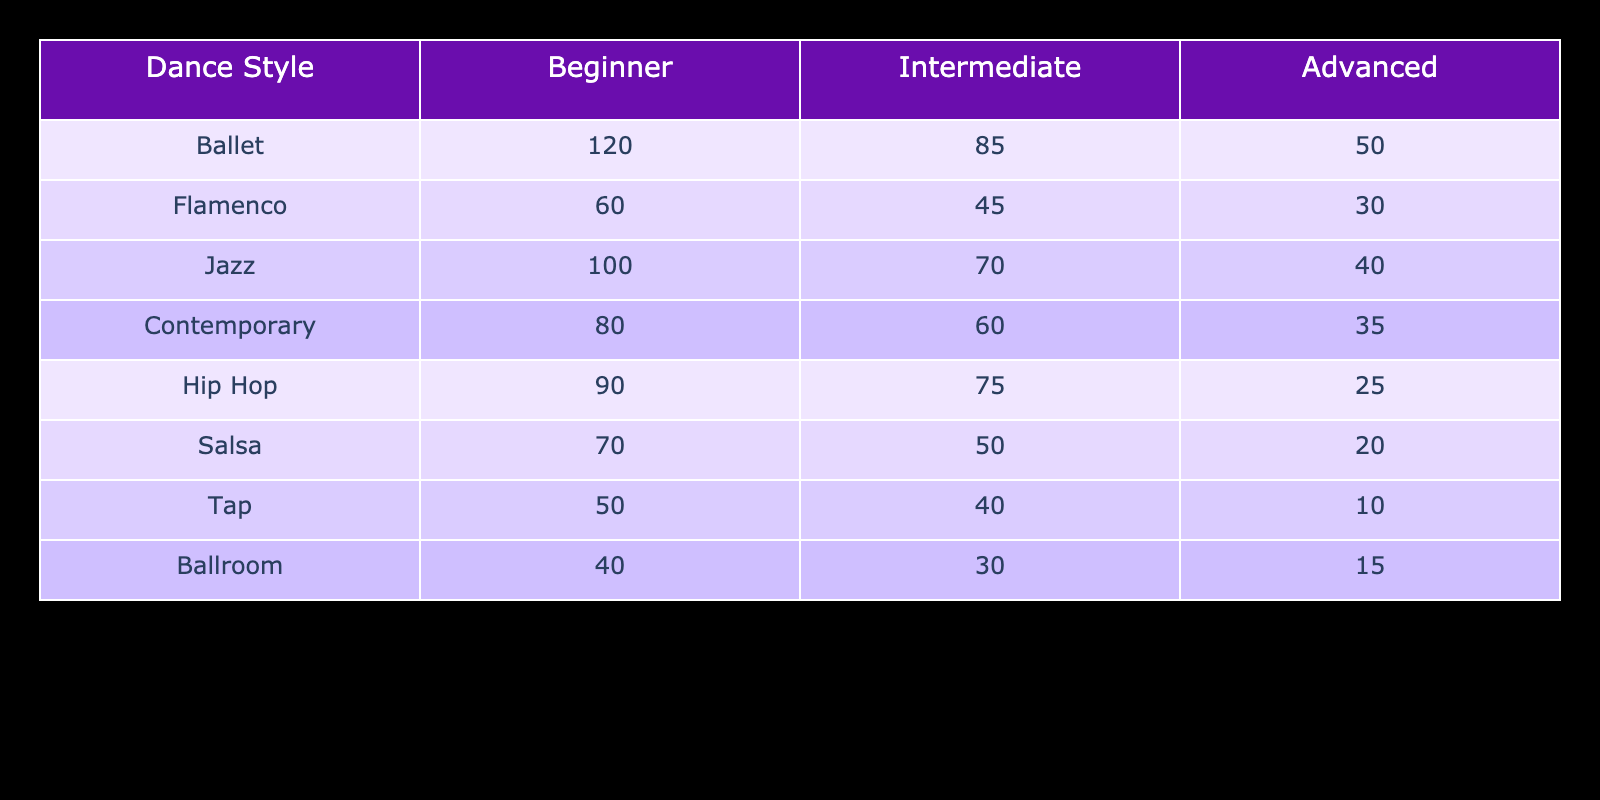What is the enrollment number for Intermediate Flamenco? The table shows that the enrollment number for the Intermediate level in Flamenco is listed under the Flamenco row and the Intermediate column. That number is 45.
Answer: 45 How many students are enrolled in Advanced Contemporary? Referring to the table, the Advanced enrollment number for Contemporary is found in the Contemporary row under the Advanced column. This value is 35.
Answer: 35 What is the total enrollment for Beginner classes across all dance styles? To find the total enrollment for Beginner classes, we need to add up the numbers from the Beginner column for each style: 120 (Ballet) + 60 (Flamenco) + 100 (Jazz) + 80 (Contemporary) + 90 (Hip Hop) + 70 (Salsa) + 50 (Tap) + 40 (Ballroom) = 610.
Answer: 610 Which dance style has the highest number of students enrolled at the Advanced level? To determine this, we look at the Advanced column and identify the highest value among the dance styles. The values are: Ballet (50), Flamenco (30), Jazz (40), Contemporary (35), Hip Hop (25), Salsa (20), Tap (10), and Ballroom (15). The highest value is 50 for Ballet.
Answer: Ballet Is there more enrollment in Beginner Jazz compared to Intermediate Jazz? Looking at the table, Beginner Jazz has 100 students, while Intermediate Jazz has 70 students. Since 100 is greater than 70, the answer is yes.
Answer: Yes What is the average number of students enrolled in Advanced classes? To find the average, we sum the enrollments in the Advanced column: 50 (Ballet) + 30 (Flamenco) + 40 (Jazz) + 35 (Contemporary) + 25 (Hip Hop) + 20 (Salsa) + 10 (Tap) + 15 (Ballroom) = 225. There are 8 styles, so the average is 225/8 = 28.125.
Answer: 28.125 How many more students are enrolled in Beginner Ballet than in Beginner Salsa? Checking the Beginner column, we find Ballet has 120 students and Salsa has 70. To find the difference, we subtract 70 from 120, which results in 50.
Answer: 50 Which dance style has the lowest enrollment in any category? We check the values of each style across all skill levels. The lowest number is found under the Tap style at the Advanced level, which has 10 students.
Answer: Tap 